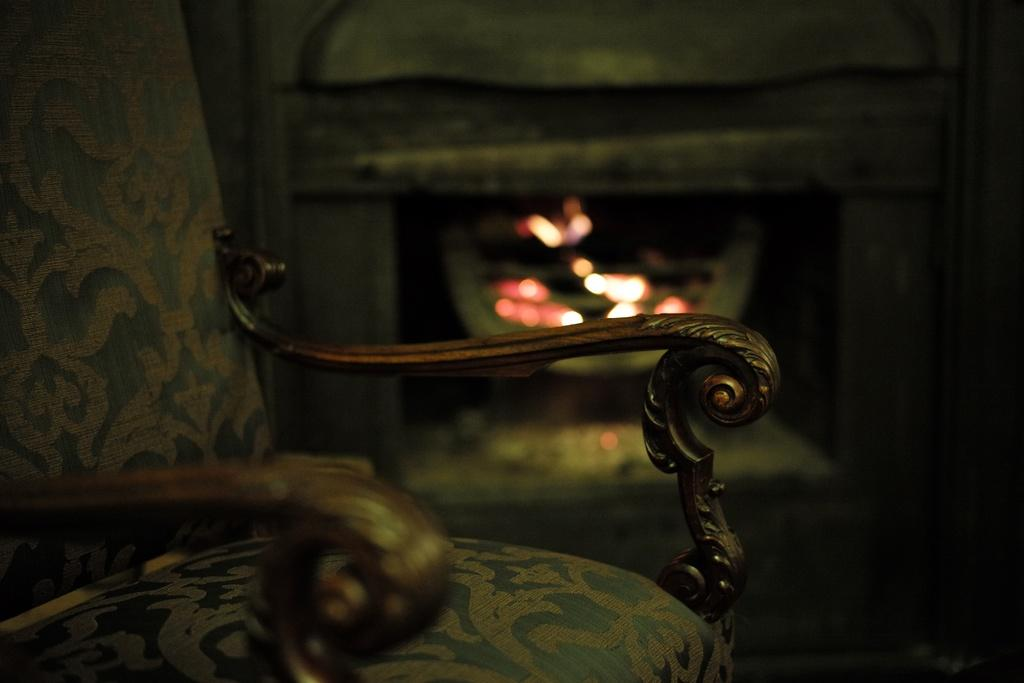What type of furniture is located on the left side of the image? There is a chair on the left side of the image. What can be seen in the middle of the image? There is a fireplace in the middle of the image. How does the turkey react to the impulse of the fireplace in the image? There is no turkey present in the image, so it cannot react to any impulses from the fireplace. 